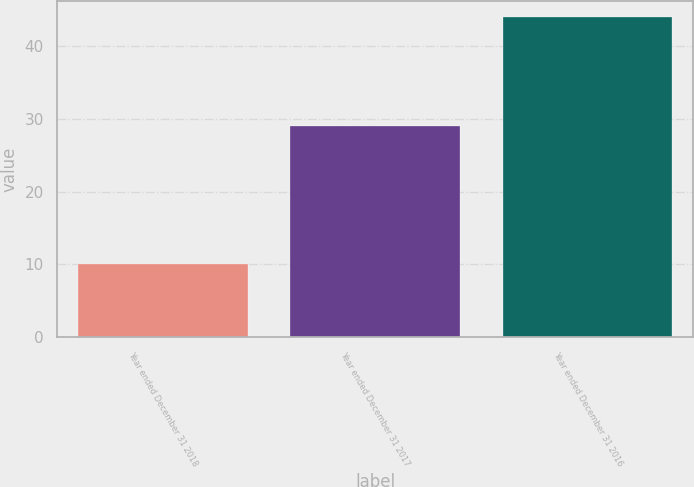<chart> <loc_0><loc_0><loc_500><loc_500><bar_chart><fcel>Year ended December 31 2018<fcel>Year ended December 31 2017<fcel>Year ended December 31 2016<nl><fcel>10<fcel>29<fcel>44<nl></chart> 